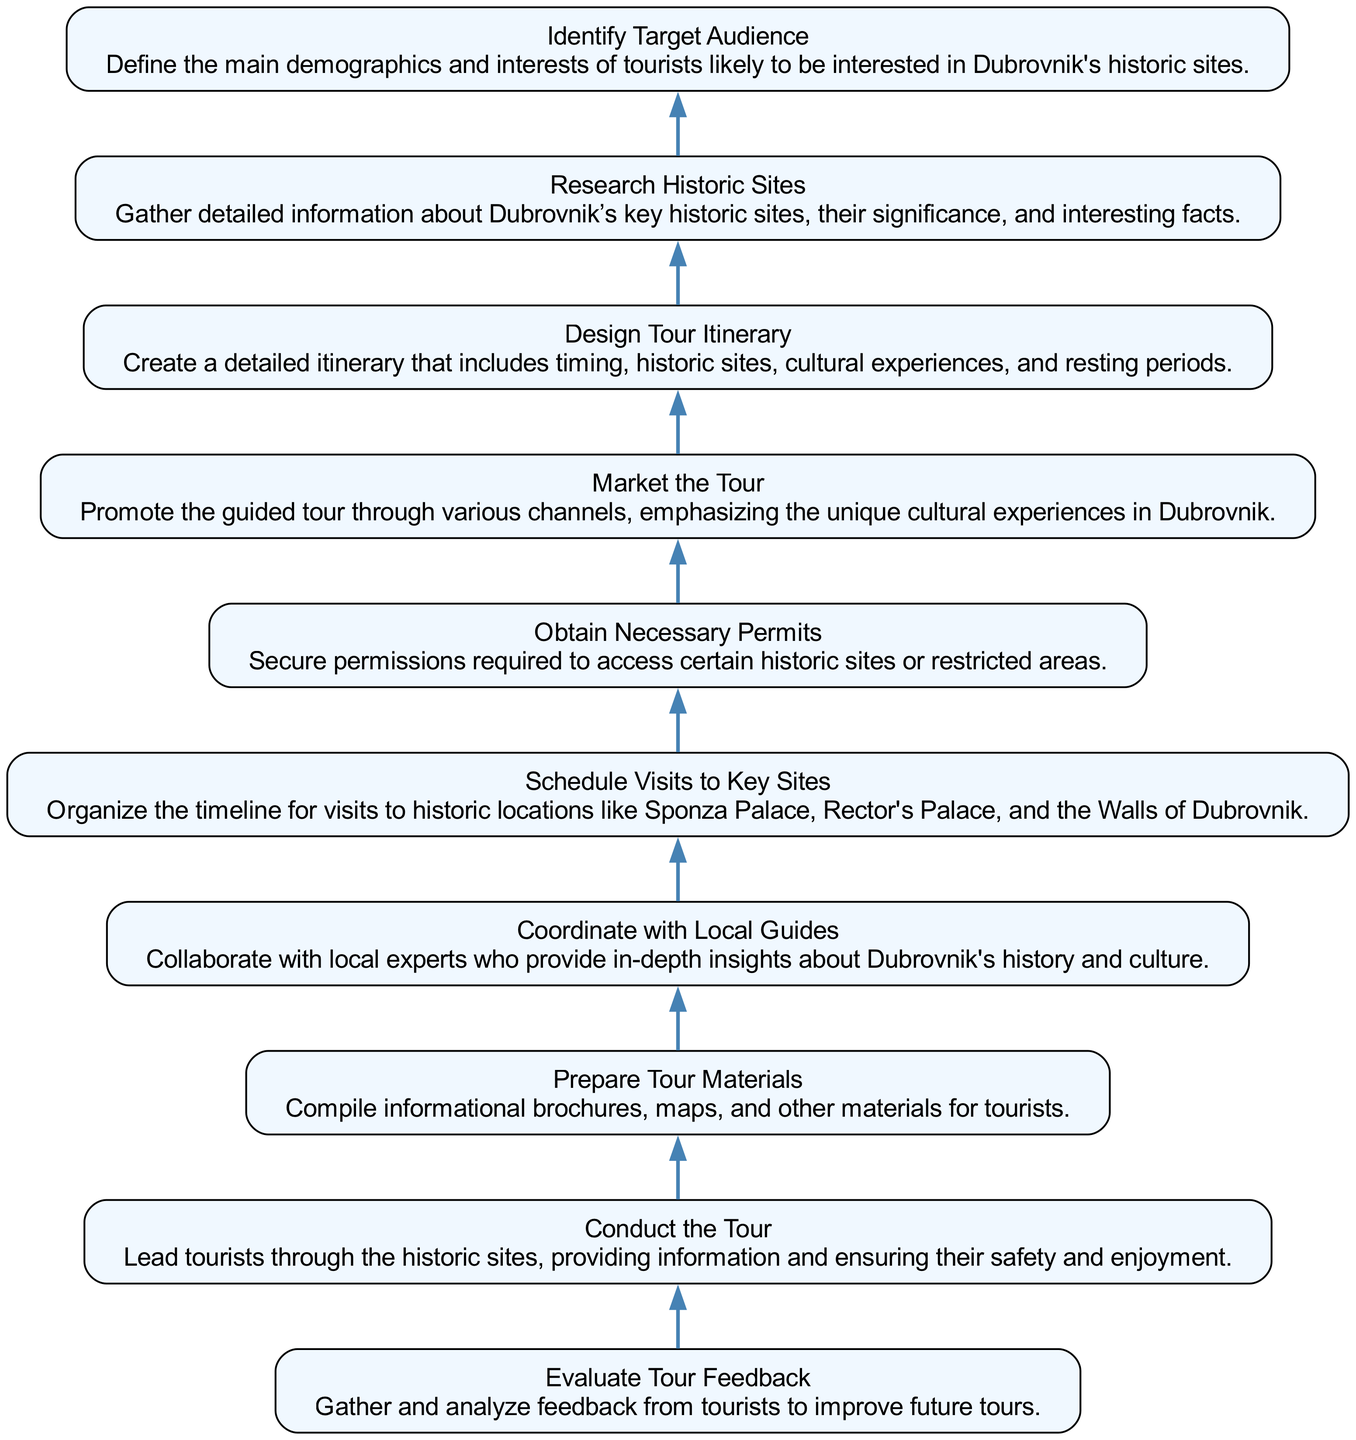What is the first step in organizing a guided tour? The diagram shows the first step at the bottom as "Identify Target Audience". This indicates that before any other actions, it is essential to determine who the tour is aimed at.
Answer: Identify Target Audience How many main steps are outlined in the diagram? Counting each node from the bottom to the top in the diagram provides the total number of steps included in the process, which is ten in total.
Answer: 10 What comes immediately after "Research Historic Sites"? Following the flow of the diagram, "Design Tour Itinerary" comes directly after "Research Historic Sites", indicating that after gathering information about historic sites, the next logical step is to create an itinerary.
Answer: Design Tour Itinerary What is the final step in the tour organization process according to the diagram? The diagram highlights that the last step at the top is "Evaluate Tour Feedback", which represents the process of gathering and analyzing feedback after the tour has been conducted.
Answer: Evaluate Tour Feedback Which step requires collaboration with local experts? Analyzing the diagram, "Coordinate with Local Guides" is the step that specifically involves working with local experts to enhance the tour's cultural and historical significance.
Answer: Coordinate with Local Guides How does "Prepare Tour Materials" relate to "Conduct the Tour"? In the sequence of the diagram, "Prepare Tour Materials" is an essential preparatory step that directly supports and enhances the effectiveness of "Conduct the Tour", ensuring tourists have the necessary information during the tour.
Answer: Supports Conduct the Tour What step involves securing permissions? Looking at the diagram, "Obtain Necessary Permits" specifically addresses the need to secure access rights for certain historic sites or restricted areas, which is crucial for the tour's success.
Answer: Obtain Necessary Permits Which step precedes "Market the Tour"? Following the flow from the bottom, "Design Tour Itinerary" is the step that comes just before "Market the Tour", indicating that a well-planned itinerary is essential for effectively promoting the tour.
Answer: Design Tour Itinerary In which step are tourists led through historic sites? The diagram indicates that "Conduct the Tour" is the step where tourists are actively led through the historic sites, outlining the main activity of the tour guide.
Answer: Conduct the Tour 